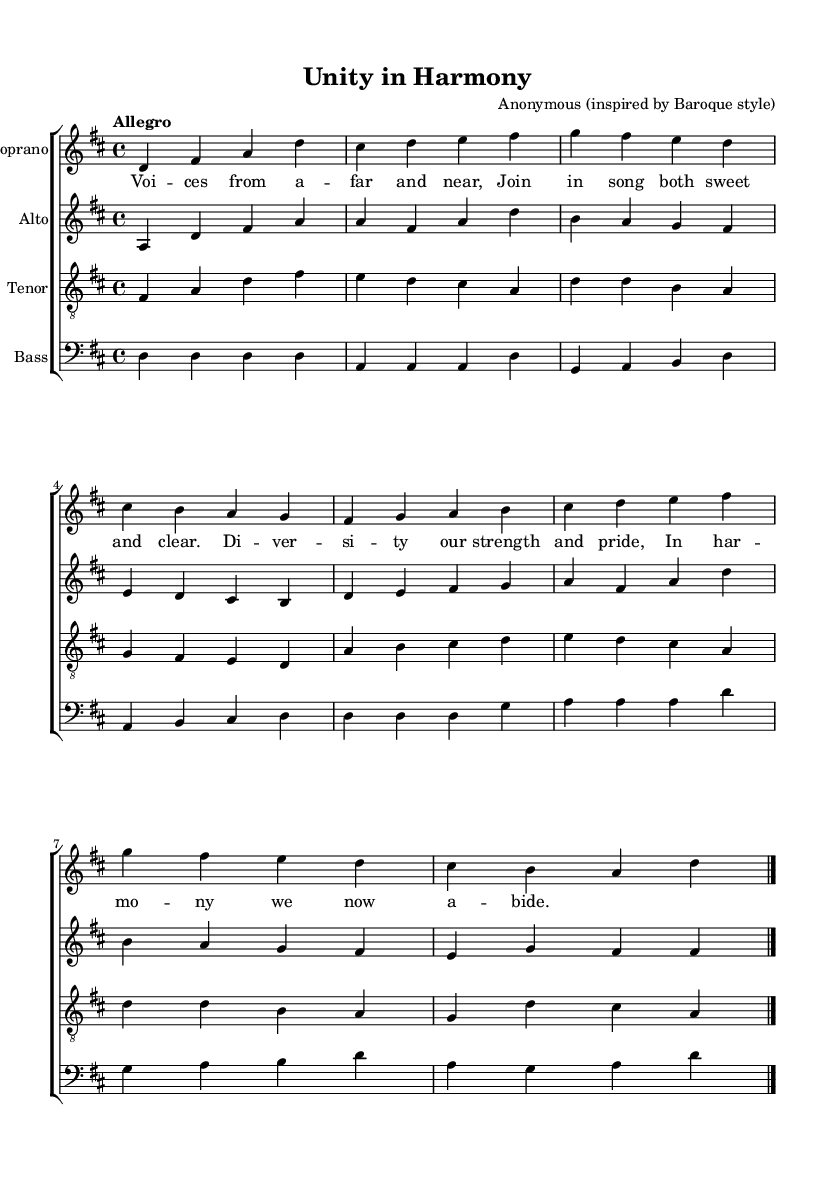What is the key signature of this music? The key signature is indicated at the beginning of the staff, showing two sharps, which correspond to D major.
Answer: D major What is the time signature of this piece? The time signature appears at the beginning of the score, displayed as a 4 over 4, indicating it is a common time signature, allowing four beats per measure.
Answer: 4/4 What is the tempo marking for this composition? The tempo marking is stated at the beginning as "Allegro," which indicates a fast and lively pace.
Answer: Allegro How many voices are in this choral work? The piece includes four separate staves, each representing a different vocal part: soprano, alto, tenor, and bass.
Answer: Four What is the term used in the lyrics that denotes harmony from different cultures? The lyrics explicitly mention "diversity," celebrating the inclusion of various cultural backgrounds in the musical expression.
Answer: Diversity What is the structural form of this choral work within the Baroque style? The piece incorporates a layered texture with multiple independent vocal lines, typical of Baroque choral compositions, allowing each voice to contribute equally to the harmony.
Answer: Polyphony What thematic concept is reflected in the lyrics of the piece? The lyrics focus on themes of unity and strength found in diversity, emphasizing collaboration among different voices and cultures.
Answer: Unity 